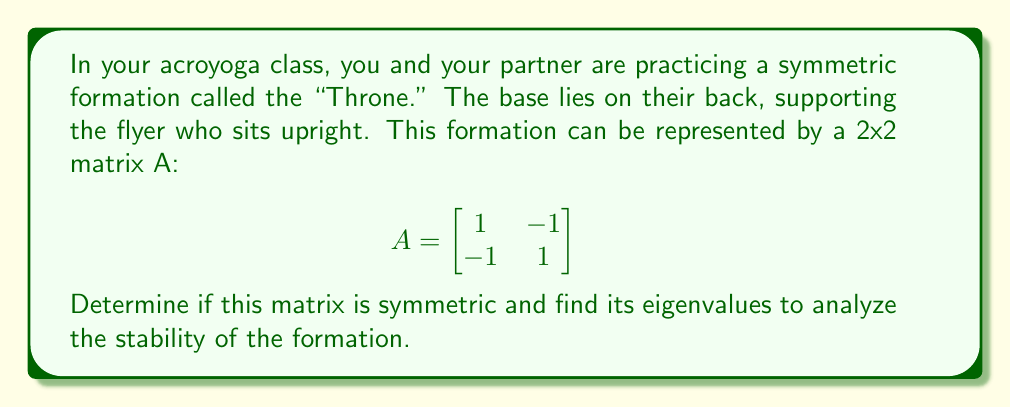Give your solution to this math problem. 1. To determine if matrix A is symmetric, we need to check if $A = A^T$:

   $A = \begin{bmatrix} 
   1 & -1 \\
   -1 & 1
   \end{bmatrix}$

   $A^T = \begin{bmatrix} 
   1 & -1 \\
   -1 & 1
   \end{bmatrix}$

   Since $A = A^T$, the matrix is symmetric.

2. To find the eigenvalues, we solve the characteristic equation:
   $det(A - \lambda I) = 0$

   $\begin{vmatrix} 
   1-\lambda & -1 \\
   -1 & 1-\lambda
   \end{vmatrix} = 0$

3. Expand the determinant:
   $(1-\lambda)(1-\lambda) - (-1)(-1) = 0$
   $(1-\lambda)^2 - 1 = 0$

4. Solve the quadratic equation:
   $(1-\lambda)^2 = 1$
   $1-\lambda = \pm 1$
   $\lambda = 1 \pm 1$

5. Therefore, the eigenvalues are:
   $\lambda_1 = 2$ and $\lambda_2 = 0$

The positive eigenvalue (2) indicates stability in one direction, while the zero eigenvalue suggests neutral stability in another direction. This aligns with the nature of the "Throne" position, where there's stability in the vertical direction but potential for rotational movement in the horizontal plane.
Answer: Symmetric; eigenvalues: 2 and 0 